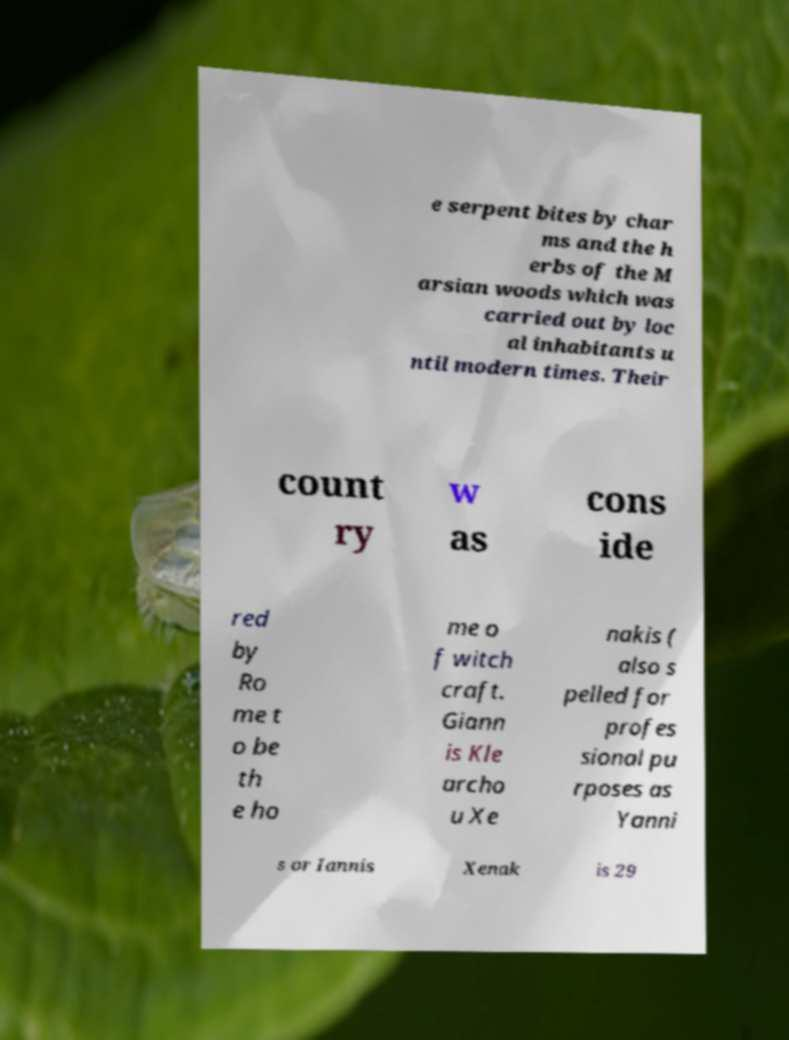For documentation purposes, I need the text within this image transcribed. Could you provide that? e serpent bites by char ms and the h erbs of the M arsian woods which was carried out by loc al inhabitants u ntil modern times. Their count ry w as cons ide red by Ro me t o be th e ho me o f witch craft. Giann is Kle archo u Xe nakis ( also s pelled for profes sional pu rposes as Yanni s or Iannis Xenak is 29 